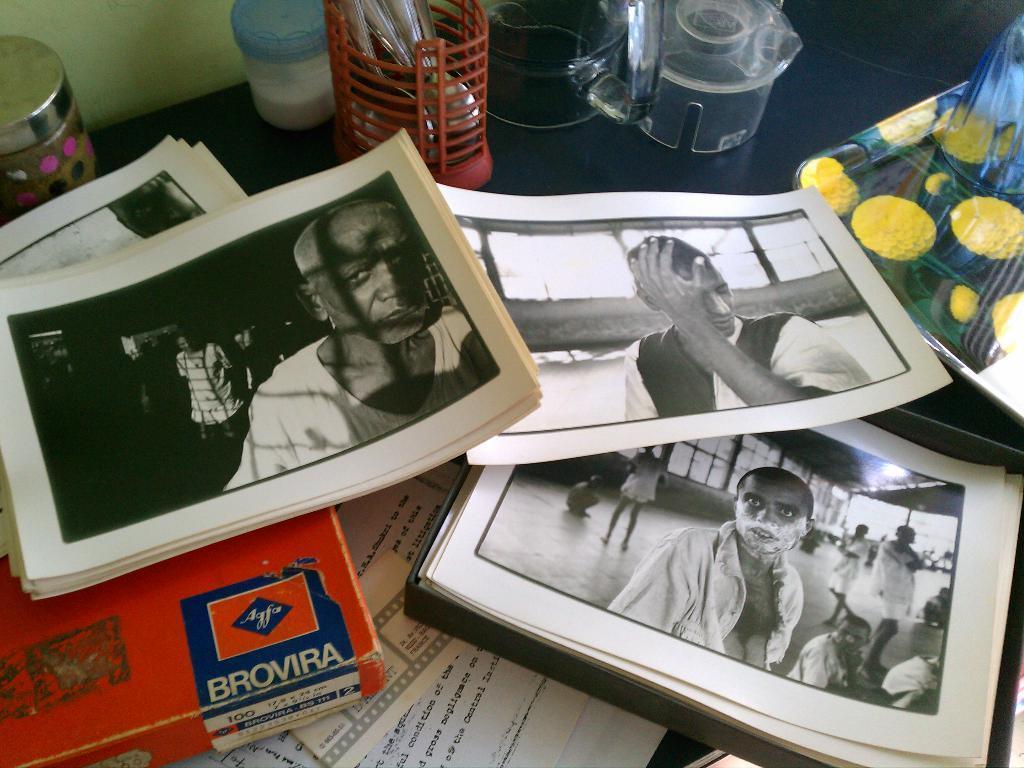In one or two sentences, can you explain what this image depicts? In this image there is a table. On the table there are many papers, Pens holder, containers, Glass jars and some other objects. 